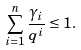<formula> <loc_0><loc_0><loc_500><loc_500>\sum _ { i = 1 } ^ { n } \frac { \gamma _ { i } } { q ^ { i } } \leq 1 .</formula> 